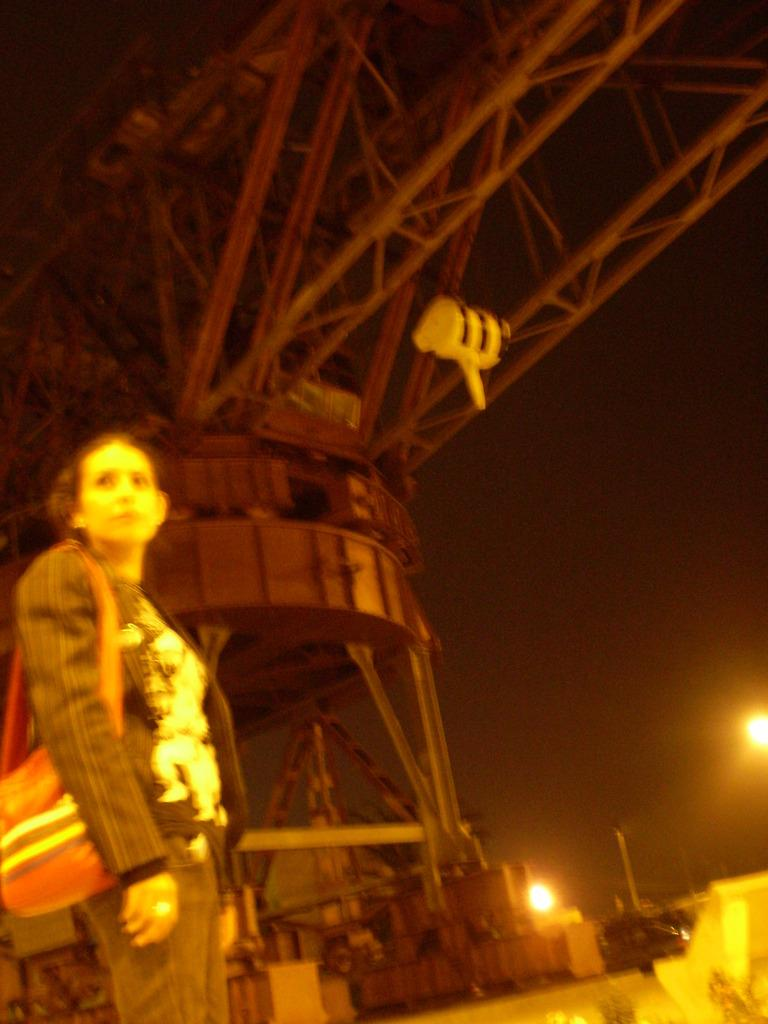What is the woman doing on the left side of the image? The woman is standing on the left side of the image. What is the woman holding in the image? The woman is holding a bag. What can be seen in the background of the image? There is machinery in the background of the image. What is visible from the right side of the image? The sky is visible from the right side of the image. How many children are playing with the bikes in the image? There are no bikes or children present in the image. What is the woman doing with her leg in the image? The woman is standing with both legs visible in the image, but there is no specific action being performed with her leg. 